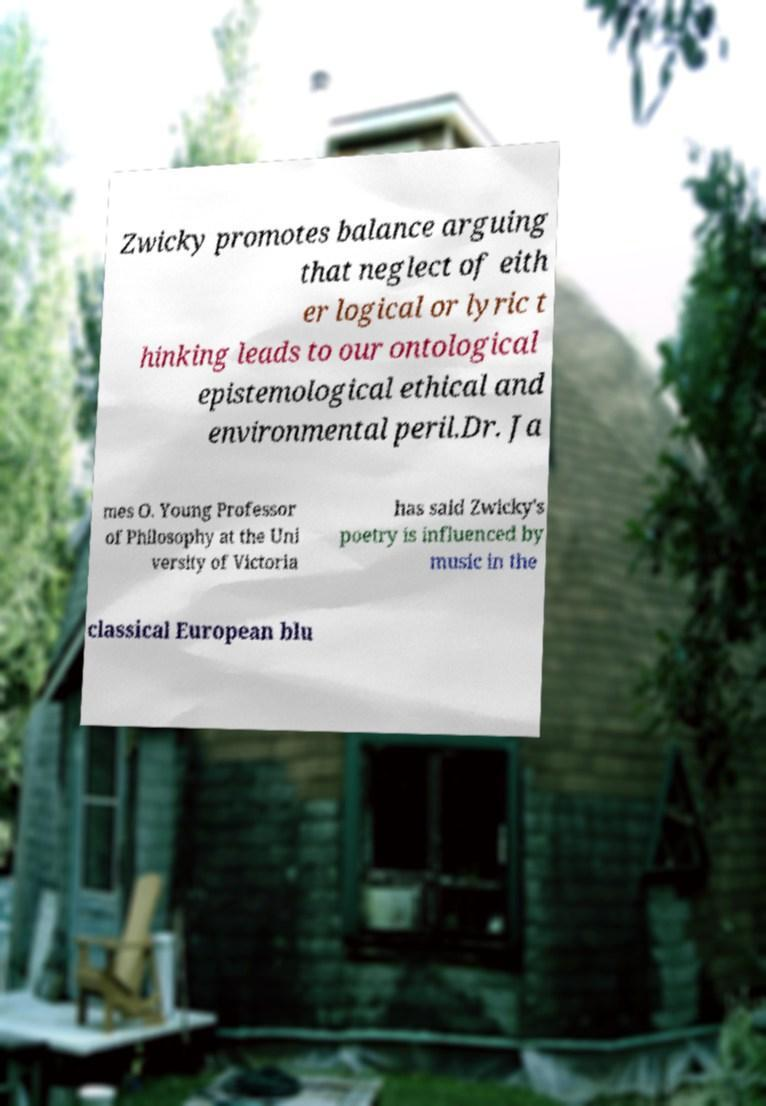There's text embedded in this image that I need extracted. Can you transcribe it verbatim? Zwicky promotes balance arguing that neglect of eith er logical or lyric t hinking leads to our ontological epistemological ethical and environmental peril.Dr. Ja mes O. Young Professor of Philosophy at the Uni versity of Victoria has said Zwicky's poetry is influenced by music in the classical European blu 